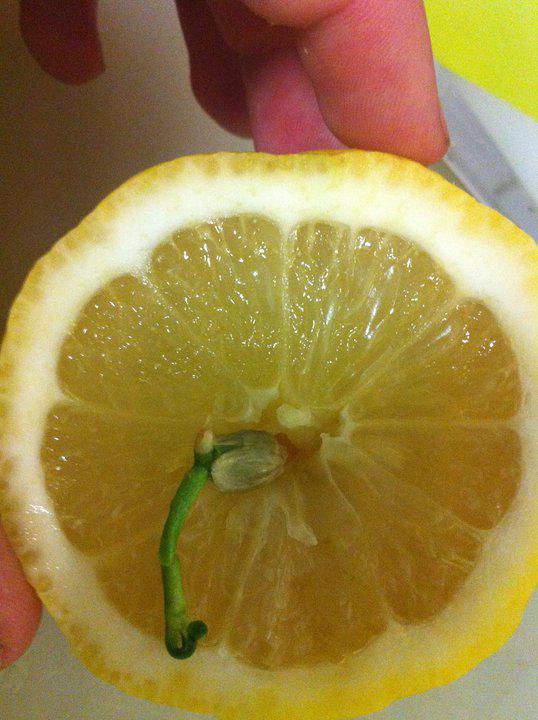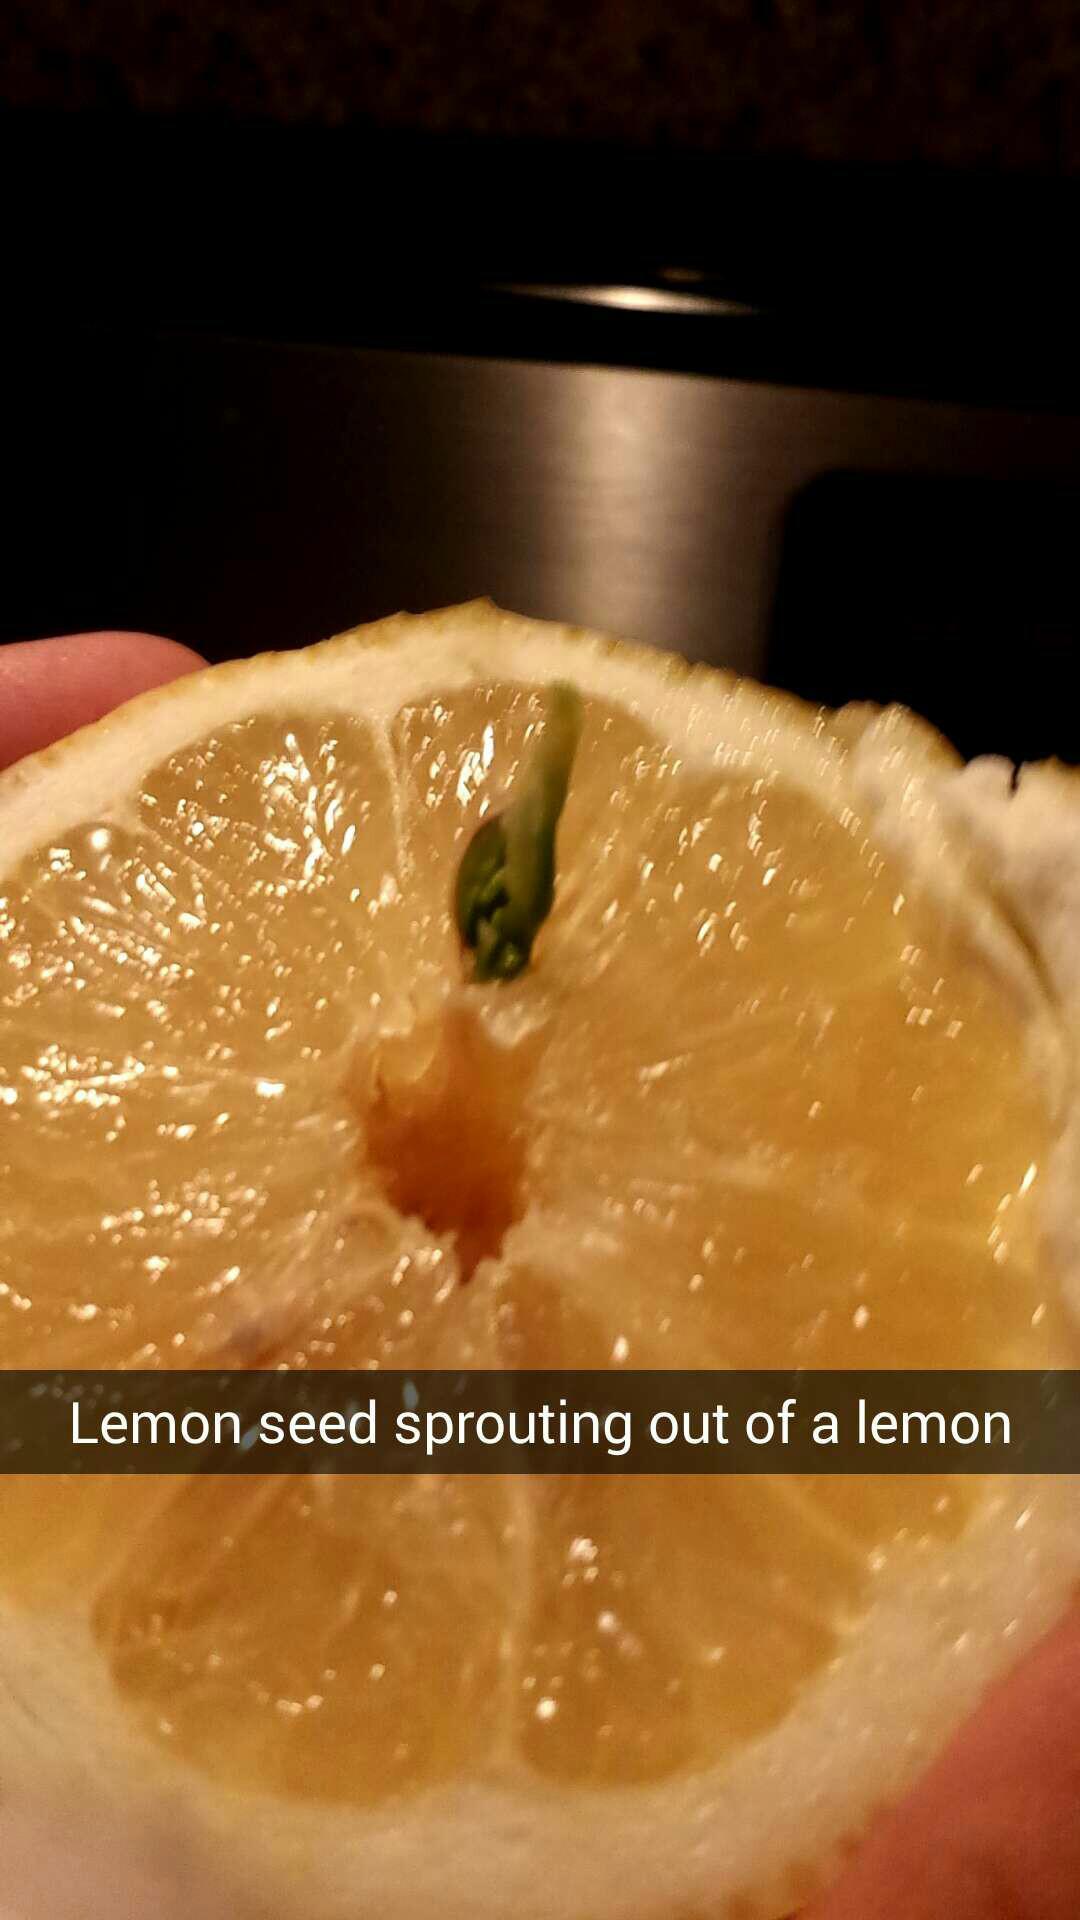The first image is the image on the left, the second image is the image on the right. Considering the images on both sides, is "An image includes a knife beside a lemon cut in half on a wooden cutting surface." valid? Answer yes or no. No. The first image is the image on the left, the second image is the image on the right. Evaluate the accuracy of this statement regarding the images: "The left and right image contains a total of three lemons.". Is it true? Answer yes or no. No. 